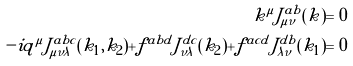Convert formula to latex. <formula><loc_0><loc_0><loc_500><loc_500>k ^ { \mu } \tilde { J } _ { \mu \nu } ^ { a b } ( k ) = 0 \\ - i q ^ { \mu } \tilde { J } _ { \mu \nu \lambda } ^ { a b c } ( k _ { 1 } , k _ { 2 } ) + f ^ { a b d } \tilde { J } _ { \nu \lambda } ^ { d c } ( k _ { 2 } ) + f ^ { a c d } \tilde { J } _ { \lambda \nu } ^ { d b } ( k _ { 1 } ) = 0</formula> 